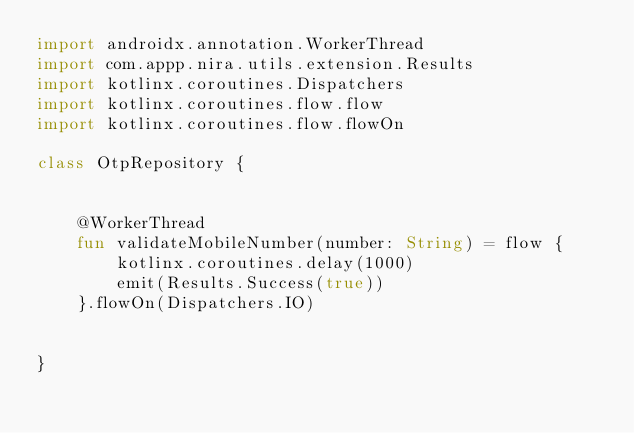<code> <loc_0><loc_0><loc_500><loc_500><_Kotlin_>import androidx.annotation.WorkerThread
import com.appp.nira.utils.extension.Results
import kotlinx.coroutines.Dispatchers
import kotlinx.coroutines.flow.flow
import kotlinx.coroutines.flow.flowOn

class OtpRepository {


    @WorkerThread
    fun validateMobileNumber(number: String) = flow {
        kotlinx.coroutines.delay(1000)
        emit(Results.Success(true))
    }.flowOn(Dispatchers.IO)


}
</code> 